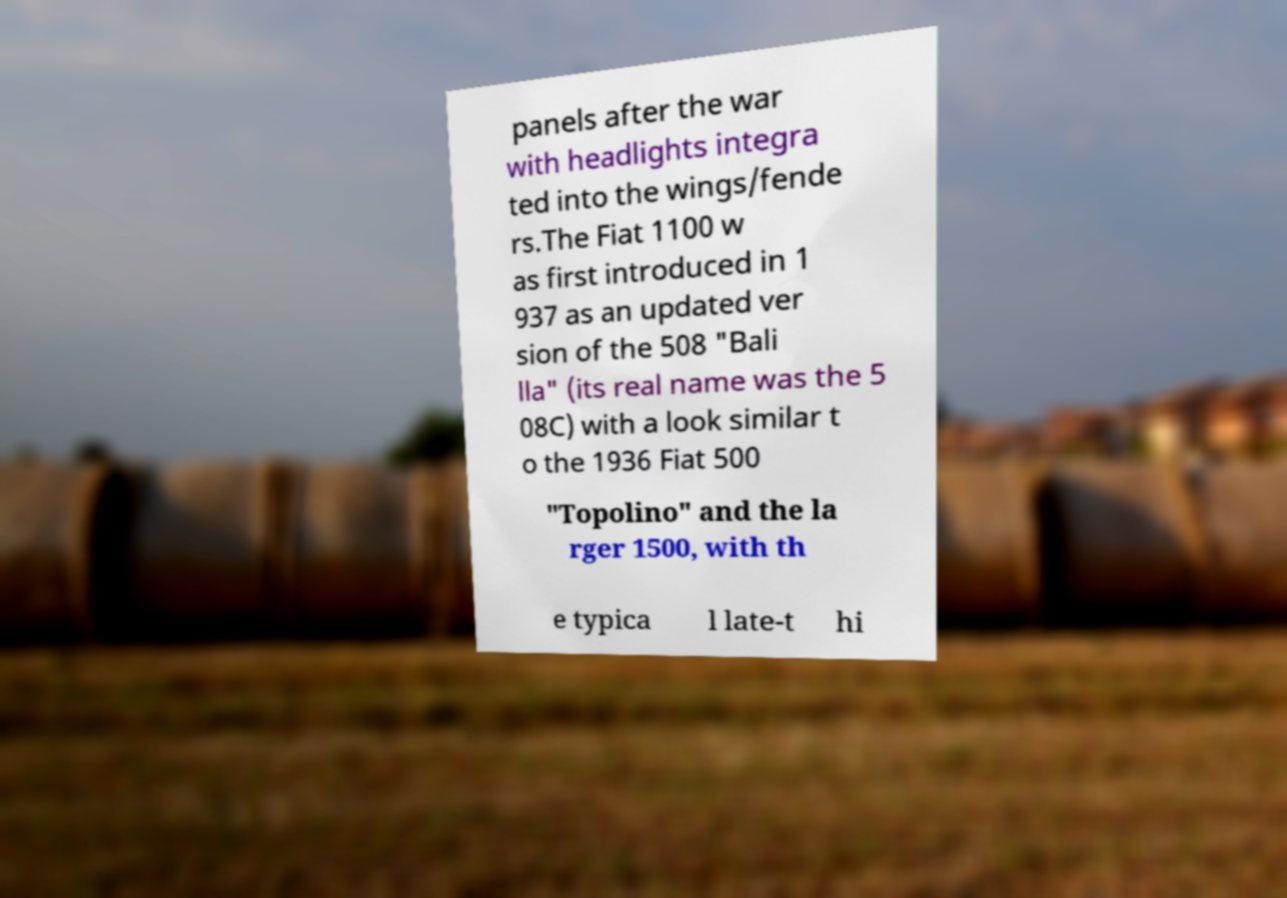For documentation purposes, I need the text within this image transcribed. Could you provide that? panels after the war with headlights integra ted into the wings/fende rs.The Fiat 1100 w as first introduced in 1 937 as an updated ver sion of the 508 "Bali lla" (its real name was the 5 08C) with a look similar t o the 1936 Fiat 500 "Topolino" and the la rger 1500, with th e typica l late-t hi 